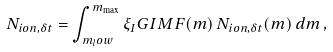<formula> <loc_0><loc_0><loc_500><loc_500>N _ { i o n , \delta t } = \int _ { m _ { l } o w } ^ { m _ { \max } } \xi _ { I } G I M F ( m ) \, N _ { i o n , \delta t } ( m ) \, d m \, ,</formula> 